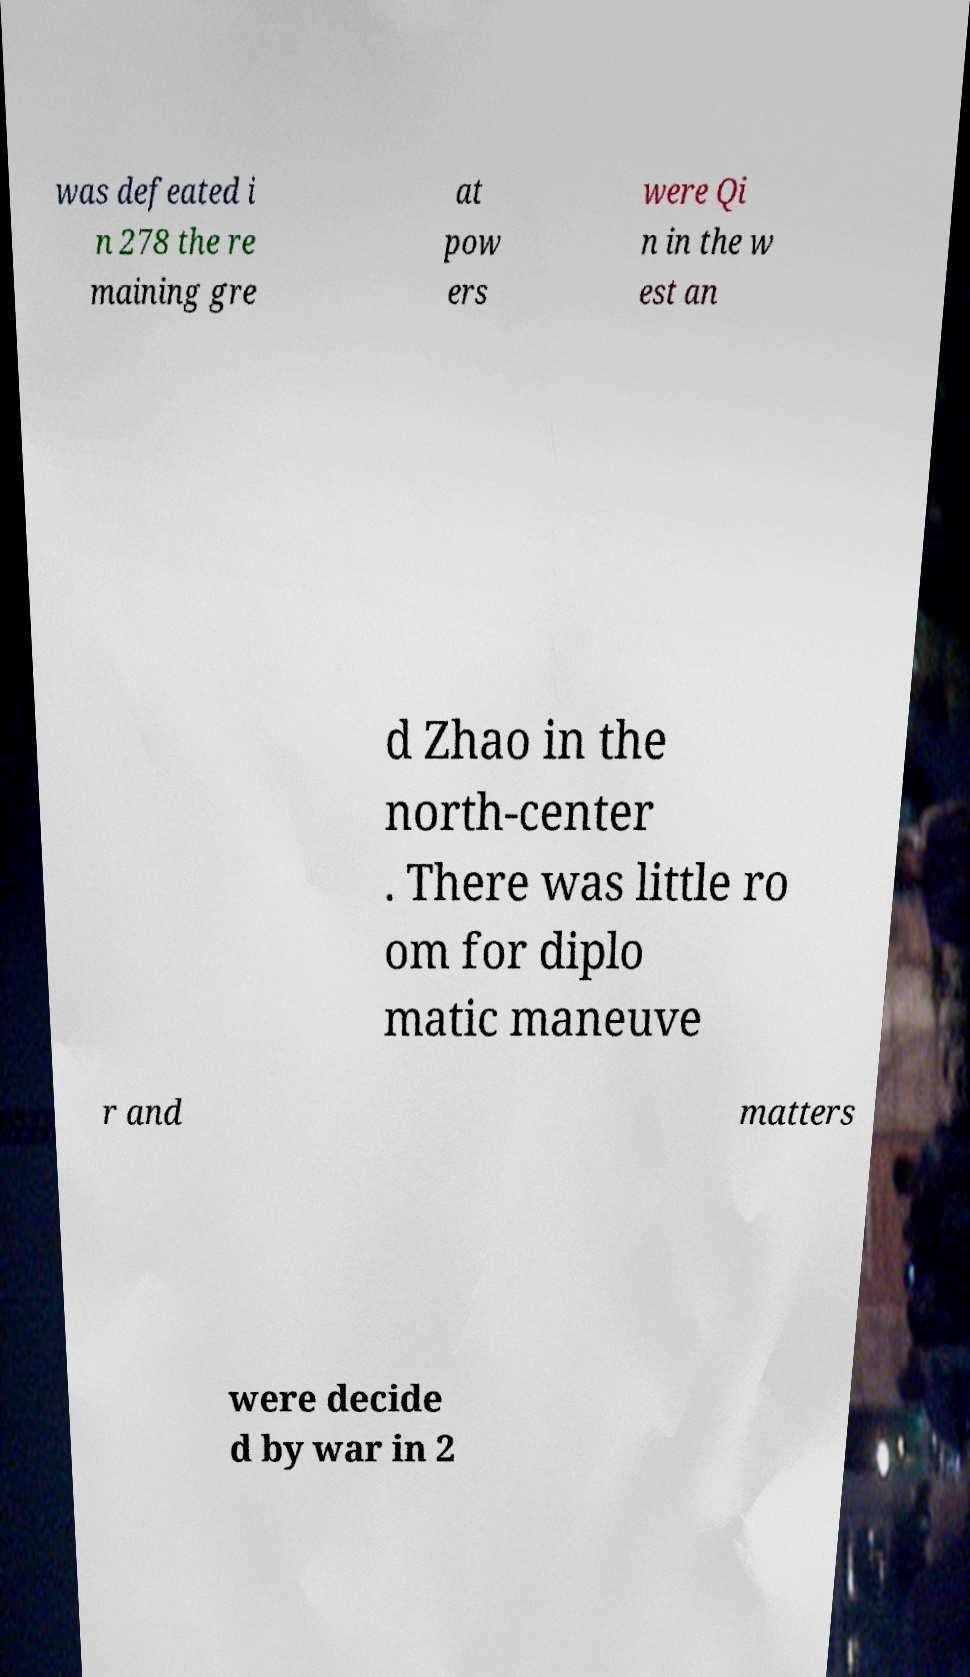Please read and relay the text visible in this image. What does it say? was defeated i n 278 the re maining gre at pow ers were Qi n in the w est an d Zhao in the north-center . There was little ro om for diplo matic maneuve r and matters were decide d by war in 2 